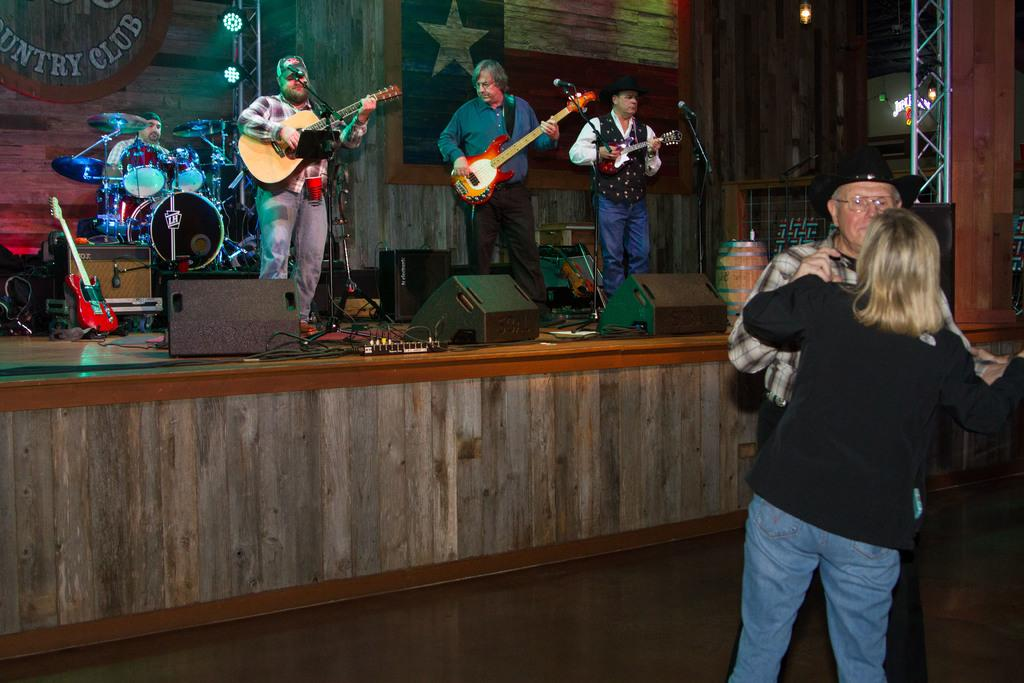How many people are playing musical instruments in the image? There are four people playing musical instruments in the image. What are the people with musical instruments doing? The four people are performing. Are there any other activities happening in the image besides playing music? Yes, there are two people dancing in the image. Where is the scene taking place? The scene takes place on a stage. What is the name of the baseball team that is performing in the image? There is no baseball team present in the image; it features four people performing with musical instruments and two people dancing. 